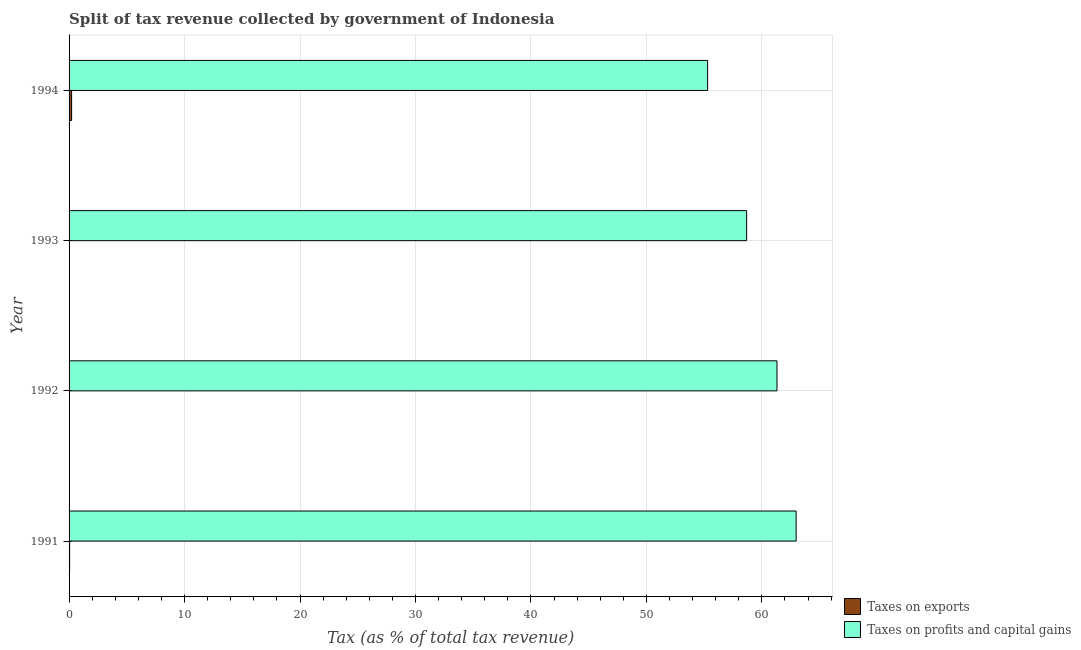How many different coloured bars are there?
Your response must be concise. 2. What is the percentage of revenue obtained from taxes on exports in 1992?
Give a very brief answer. 0.02. Across all years, what is the maximum percentage of revenue obtained from taxes on exports?
Offer a terse response. 0.22. Across all years, what is the minimum percentage of revenue obtained from taxes on profits and capital gains?
Offer a terse response. 55.3. What is the total percentage of revenue obtained from taxes on profits and capital gains in the graph?
Ensure brevity in your answer.  238.26. What is the difference between the percentage of revenue obtained from taxes on profits and capital gains in 1991 and that in 1994?
Make the answer very short. 7.66. What is the difference between the percentage of revenue obtained from taxes on exports in 1992 and the percentage of revenue obtained from taxes on profits and capital gains in 1991?
Your response must be concise. -62.95. What is the average percentage of revenue obtained from taxes on exports per year?
Provide a short and direct response. 0.08. In the year 1993, what is the difference between the percentage of revenue obtained from taxes on profits and capital gains and percentage of revenue obtained from taxes on exports?
Offer a terse response. 58.65. What is the ratio of the percentage of revenue obtained from taxes on exports in 1992 to that in 1993?
Ensure brevity in your answer.  0.64. Is the difference between the percentage of revenue obtained from taxes on profits and capital gains in 1993 and 1994 greater than the difference between the percentage of revenue obtained from taxes on exports in 1993 and 1994?
Provide a succinct answer. Yes. What is the difference between the highest and the second highest percentage of revenue obtained from taxes on profits and capital gains?
Your answer should be compact. 1.66. What is the difference between the highest and the lowest percentage of revenue obtained from taxes on profits and capital gains?
Your answer should be very brief. 7.66. In how many years, is the percentage of revenue obtained from taxes on profits and capital gains greater than the average percentage of revenue obtained from taxes on profits and capital gains taken over all years?
Your answer should be compact. 2. What does the 2nd bar from the top in 1992 represents?
Give a very brief answer. Taxes on exports. What does the 1st bar from the bottom in 1991 represents?
Your answer should be compact. Taxes on exports. Are all the bars in the graph horizontal?
Your answer should be very brief. Yes. Does the graph contain grids?
Ensure brevity in your answer.  Yes. Where does the legend appear in the graph?
Ensure brevity in your answer.  Bottom right. How many legend labels are there?
Offer a terse response. 2. How are the legend labels stacked?
Keep it short and to the point. Vertical. What is the title of the graph?
Ensure brevity in your answer.  Split of tax revenue collected by government of Indonesia. Does "Net National savings" appear as one of the legend labels in the graph?
Your answer should be very brief. No. What is the label or title of the X-axis?
Offer a very short reply. Tax (as % of total tax revenue). What is the label or title of the Y-axis?
Your answer should be very brief. Year. What is the Tax (as % of total tax revenue) in Taxes on exports in 1991?
Offer a terse response. 0.05. What is the Tax (as % of total tax revenue) in Taxes on profits and capital gains in 1991?
Provide a short and direct response. 62.97. What is the Tax (as % of total tax revenue) of Taxes on exports in 1992?
Your answer should be compact. 0.02. What is the Tax (as % of total tax revenue) in Taxes on profits and capital gains in 1992?
Give a very brief answer. 61.31. What is the Tax (as % of total tax revenue) in Taxes on exports in 1993?
Your response must be concise. 0.03. What is the Tax (as % of total tax revenue) of Taxes on profits and capital gains in 1993?
Your answer should be compact. 58.68. What is the Tax (as % of total tax revenue) of Taxes on exports in 1994?
Your response must be concise. 0.22. What is the Tax (as % of total tax revenue) of Taxes on profits and capital gains in 1994?
Give a very brief answer. 55.3. Across all years, what is the maximum Tax (as % of total tax revenue) in Taxes on exports?
Provide a short and direct response. 0.22. Across all years, what is the maximum Tax (as % of total tax revenue) of Taxes on profits and capital gains?
Your answer should be very brief. 62.97. Across all years, what is the minimum Tax (as % of total tax revenue) of Taxes on exports?
Offer a terse response. 0.02. Across all years, what is the minimum Tax (as % of total tax revenue) of Taxes on profits and capital gains?
Offer a very short reply. 55.3. What is the total Tax (as % of total tax revenue) of Taxes on exports in the graph?
Provide a short and direct response. 0.32. What is the total Tax (as % of total tax revenue) in Taxes on profits and capital gains in the graph?
Provide a short and direct response. 238.26. What is the difference between the Tax (as % of total tax revenue) in Taxes on exports in 1991 and that in 1992?
Your answer should be compact. 0.03. What is the difference between the Tax (as % of total tax revenue) in Taxes on profits and capital gains in 1991 and that in 1992?
Give a very brief answer. 1.66. What is the difference between the Tax (as % of total tax revenue) in Taxes on exports in 1991 and that in 1993?
Make the answer very short. 0.02. What is the difference between the Tax (as % of total tax revenue) of Taxes on profits and capital gains in 1991 and that in 1993?
Make the answer very short. 4.29. What is the difference between the Tax (as % of total tax revenue) of Taxes on exports in 1991 and that in 1994?
Your answer should be compact. -0.17. What is the difference between the Tax (as % of total tax revenue) of Taxes on profits and capital gains in 1991 and that in 1994?
Your answer should be compact. 7.66. What is the difference between the Tax (as % of total tax revenue) in Taxes on exports in 1992 and that in 1993?
Your response must be concise. -0.01. What is the difference between the Tax (as % of total tax revenue) of Taxes on profits and capital gains in 1992 and that in 1993?
Make the answer very short. 2.63. What is the difference between the Tax (as % of total tax revenue) of Taxes on exports in 1992 and that in 1994?
Your answer should be compact. -0.2. What is the difference between the Tax (as % of total tax revenue) in Taxes on profits and capital gains in 1992 and that in 1994?
Provide a short and direct response. 6.01. What is the difference between the Tax (as % of total tax revenue) in Taxes on exports in 1993 and that in 1994?
Provide a short and direct response. -0.19. What is the difference between the Tax (as % of total tax revenue) in Taxes on profits and capital gains in 1993 and that in 1994?
Ensure brevity in your answer.  3.38. What is the difference between the Tax (as % of total tax revenue) of Taxes on exports in 1991 and the Tax (as % of total tax revenue) of Taxes on profits and capital gains in 1992?
Give a very brief answer. -61.26. What is the difference between the Tax (as % of total tax revenue) in Taxes on exports in 1991 and the Tax (as % of total tax revenue) in Taxes on profits and capital gains in 1993?
Provide a succinct answer. -58.63. What is the difference between the Tax (as % of total tax revenue) in Taxes on exports in 1991 and the Tax (as % of total tax revenue) in Taxes on profits and capital gains in 1994?
Your answer should be very brief. -55.25. What is the difference between the Tax (as % of total tax revenue) of Taxes on exports in 1992 and the Tax (as % of total tax revenue) of Taxes on profits and capital gains in 1993?
Offer a very short reply. -58.66. What is the difference between the Tax (as % of total tax revenue) in Taxes on exports in 1992 and the Tax (as % of total tax revenue) in Taxes on profits and capital gains in 1994?
Give a very brief answer. -55.28. What is the difference between the Tax (as % of total tax revenue) in Taxes on exports in 1993 and the Tax (as % of total tax revenue) in Taxes on profits and capital gains in 1994?
Offer a terse response. -55.27. What is the average Tax (as % of total tax revenue) of Taxes on exports per year?
Provide a short and direct response. 0.08. What is the average Tax (as % of total tax revenue) in Taxes on profits and capital gains per year?
Provide a short and direct response. 59.57. In the year 1991, what is the difference between the Tax (as % of total tax revenue) in Taxes on exports and Tax (as % of total tax revenue) in Taxes on profits and capital gains?
Your answer should be compact. -62.92. In the year 1992, what is the difference between the Tax (as % of total tax revenue) of Taxes on exports and Tax (as % of total tax revenue) of Taxes on profits and capital gains?
Your answer should be very brief. -61.29. In the year 1993, what is the difference between the Tax (as % of total tax revenue) of Taxes on exports and Tax (as % of total tax revenue) of Taxes on profits and capital gains?
Make the answer very short. -58.65. In the year 1994, what is the difference between the Tax (as % of total tax revenue) in Taxes on exports and Tax (as % of total tax revenue) in Taxes on profits and capital gains?
Provide a short and direct response. -55.08. What is the ratio of the Tax (as % of total tax revenue) of Taxes on exports in 1991 to that in 1992?
Provide a succinct answer. 2.57. What is the ratio of the Tax (as % of total tax revenue) of Taxes on exports in 1991 to that in 1993?
Provide a succinct answer. 1.64. What is the ratio of the Tax (as % of total tax revenue) in Taxes on profits and capital gains in 1991 to that in 1993?
Provide a short and direct response. 1.07. What is the ratio of the Tax (as % of total tax revenue) in Taxes on exports in 1991 to that in 1994?
Offer a terse response. 0.22. What is the ratio of the Tax (as % of total tax revenue) of Taxes on profits and capital gains in 1991 to that in 1994?
Offer a very short reply. 1.14. What is the ratio of the Tax (as % of total tax revenue) of Taxes on exports in 1992 to that in 1993?
Keep it short and to the point. 0.64. What is the ratio of the Tax (as % of total tax revenue) of Taxes on profits and capital gains in 1992 to that in 1993?
Provide a succinct answer. 1.04. What is the ratio of the Tax (as % of total tax revenue) in Taxes on exports in 1992 to that in 1994?
Give a very brief answer. 0.09. What is the ratio of the Tax (as % of total tax revenue) of Taxes on profits and capital gains in 1992 to that in 1994?
Provide a succinct answer. 1.11. What is the ratio of the Tax (as % of total tax revenue) of Taxes on exports in 1993 to that in 1994?
Offer a very short reply. 0.13. What is the ratio of the Tax (as % of total tax revenue) in Taxes on profits and capital gains in 1993 to that in 1994?
Provide a succinct answer. 1.06. What is the difference between the highest and the second highest Tax (as % of total tax revenue) of Taxes on exports?
Ensure brevity in your answer.  0.17. What is the difference between the highest and the second highest Tax (as % of total tax revenue) of Taxes on profits and capital gains?
Your answer should be compact. 1.66. What is the difference between the highest and the lowest Tax (as % of total tax revenue) of Taxes on exports?
Your response must be concise. 0.2. What is the difference between the highest and the lowest Tax (as % of total tax revenue) in Taxes on profits and capital gains?
Your answer should be compact. 7.66. 